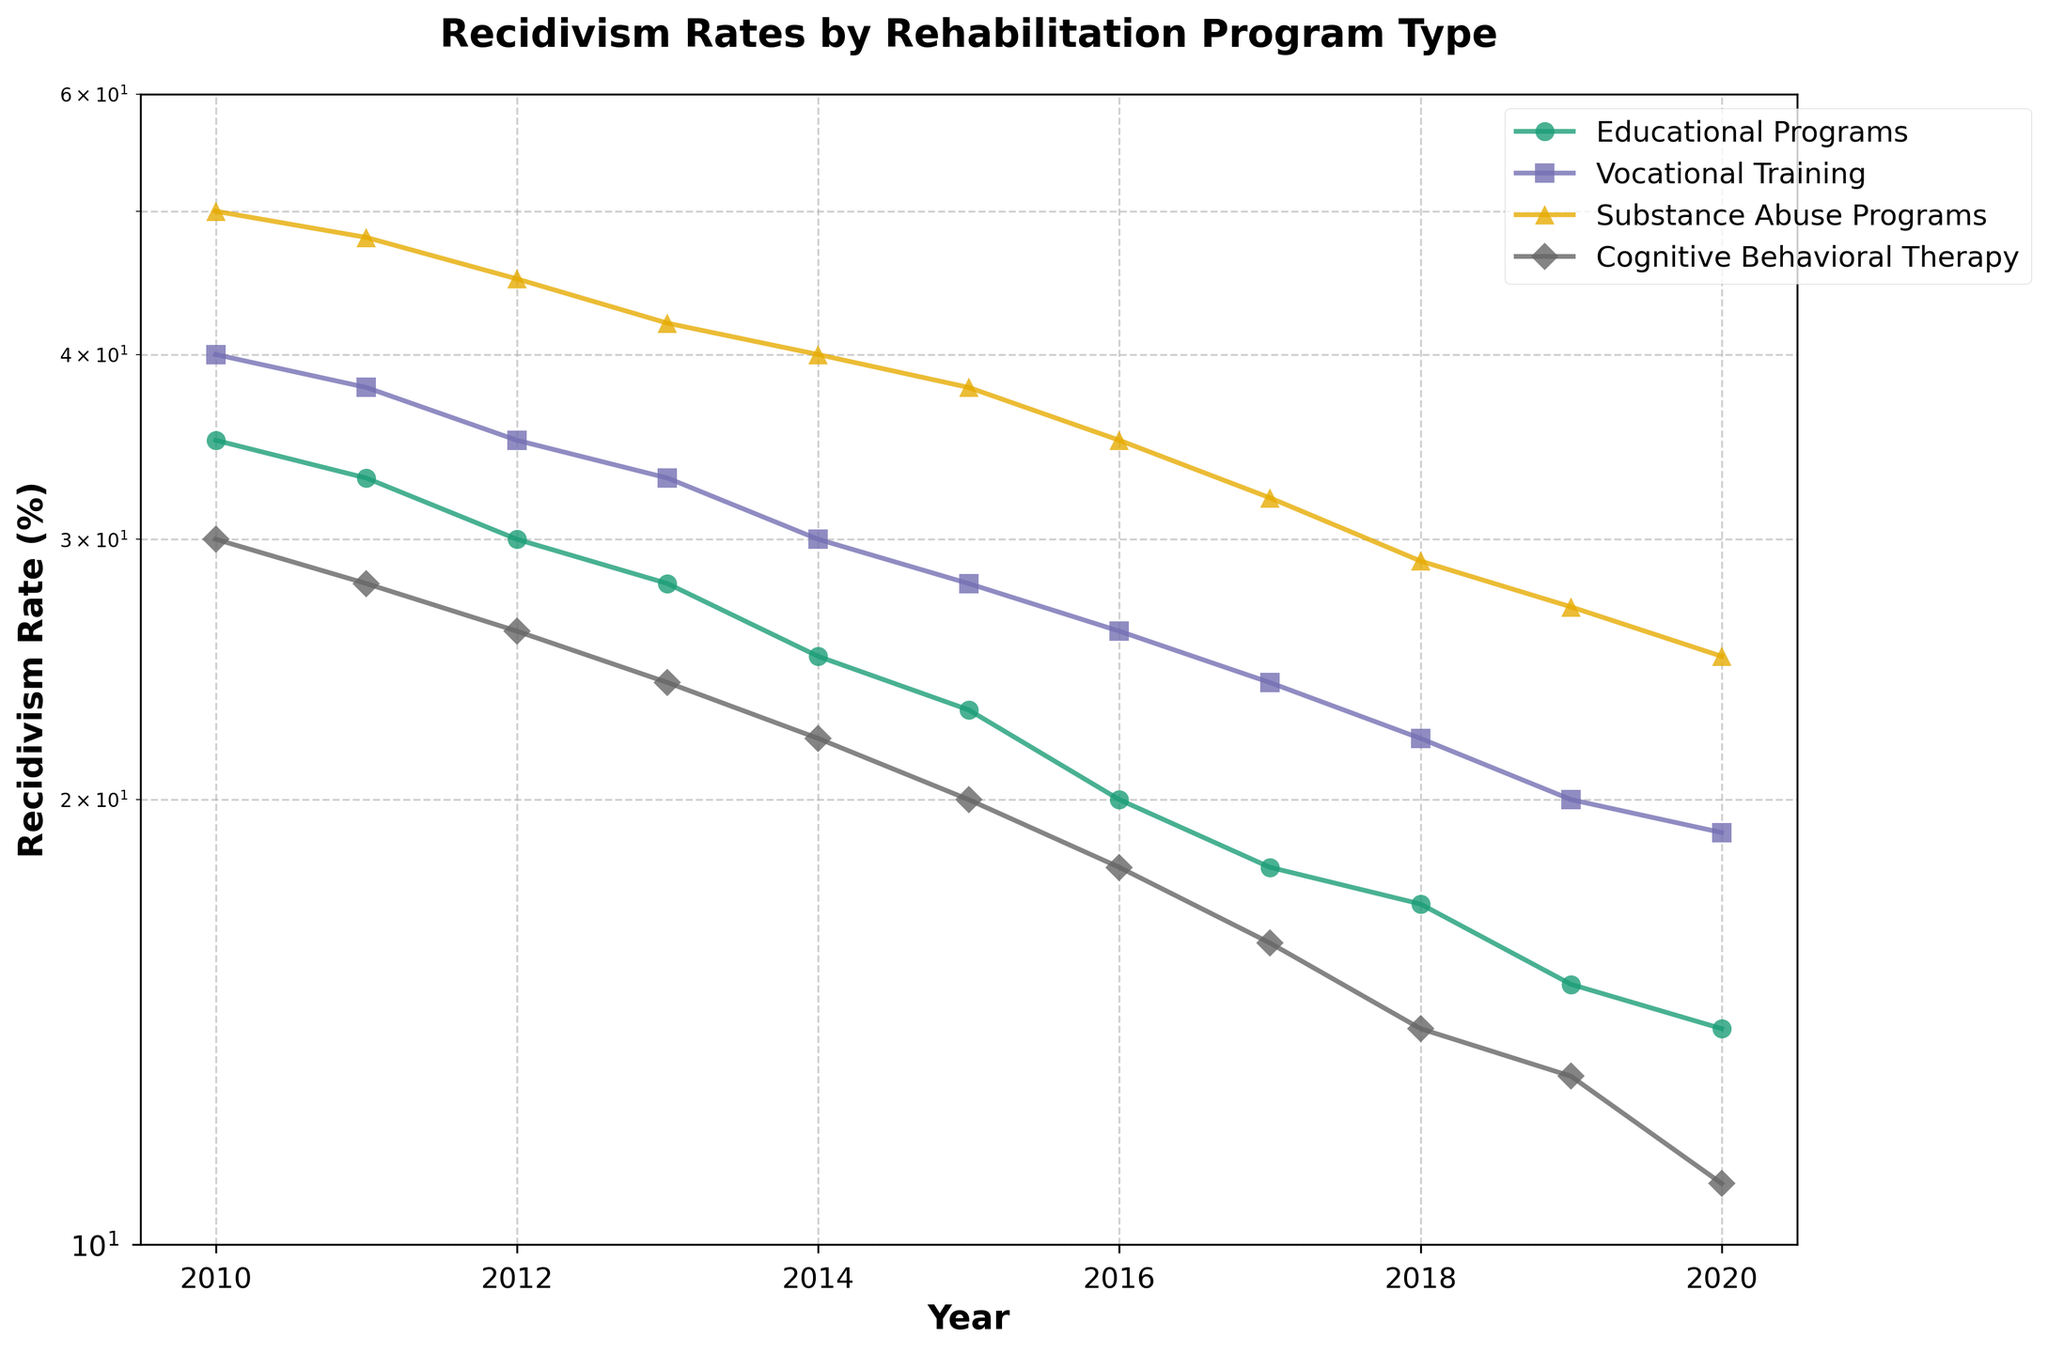Which rehabilitation program type started with the highest recidivism rate in 2010? By looking at the plot for the year 2010, identify the program type with the highest data point on the y-axis.
Answer: Substance Abuse Programs What is the overall trend in recidivism rates for Cognitive Behavioral Therapy from 2010 to 2020? Observing the line plot for Cognitive Behavioral Therapy, note the direction of the trend from 2010 to 2020.
Answer: Downward Between which years did the Vocational Training program see the steepest decline in recidivism rates? Examine the line segment for Vocational Training and identify the years with the most significant drop.
Answer: 2010 to 2011 Which rehabilitation program type had the lowest recidivism rate in 2020? Look at the y-axis value in 2020 and identify the program type with the lowest data point.
Answer: Cognitive Behavioral Therapy What is the difference in recidivism rates between Educational Programs and Substance Abuse Programs in 2020? Retrieve the recidivism rates for both programs in 2020 and subtract the rate for Educational Programs from that of Substance Abuse Programs.
Answer: 11% How many program types show a recidivism rate of 25% or lower by 2020? Count the number of program types whose plot lines reach at or under 25% on the y-axis by 2020.
Answer: 4 Compare the rate of decline in recidivism rates for Educational Programs and Vocational Training from 2010 to 2020. Which one shows a greater rate of decline? Calculate the difference in recidivism rates from 2010 to 2020 for Educational Programs and Vocational Training and compare the two.
Answer: Educational Programs Which two rehabilitation program types had the closest recidivism rates in 2020? Examine the data points for 2020 and identify the two program types that have the closest y-axis values.
Answer: Vocational Training and Substance Abuse Programs Out of the four program types, which consistently had the highest recidivism rates over the entire period of 2010 to 2020? Observe all the lines and check which program consistently occupies the highest positions on the y-axis throughout the period.
Answer: Substance Abuse Programs 